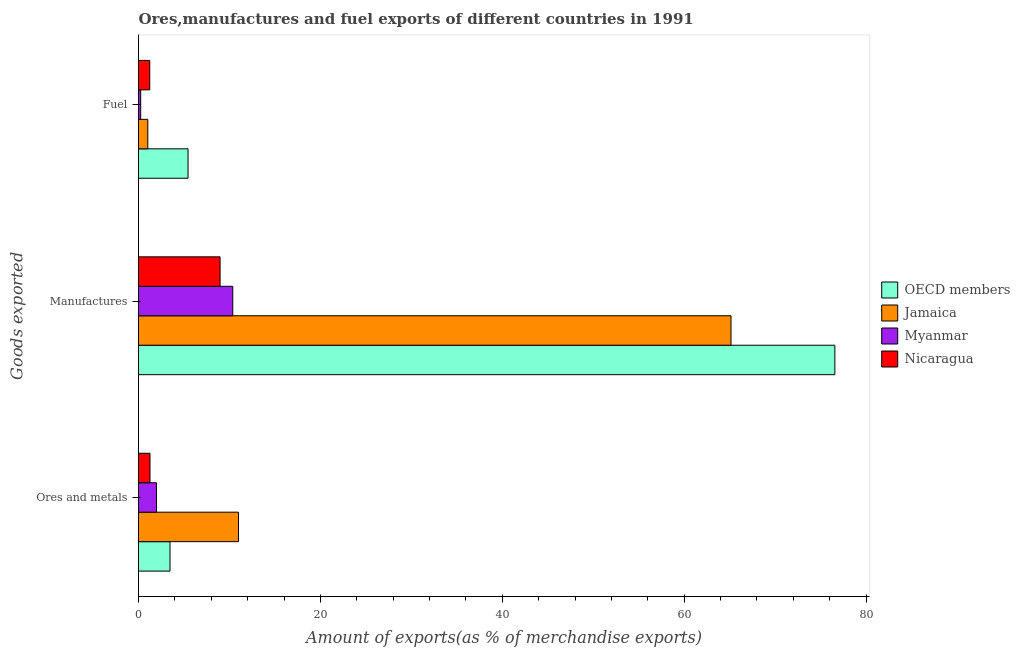How many different coloured bars are there?
Offer a terse response. 4. How many groups of bars are there?
Your answer should be compact. 3. Are the number of bars on each tick of the Y-axis equal?
Offer a very short reply. Yes. How many bars are there on the 2nd tick from the top?
Keep it short and to the point. 4. What is the label of the 3rd group of bars from the top?
Provide a short and direct response. Ores and metals. What is the percentage of fuel exports in OECD members?
Provide a short and direct response. 5.45. Across all countries, what is the maximum percentage of ores and metals exports?
Give a very brief answer. 10.99. Across all countries, what is the minimum percentage of ores and metals exports?
Provide a succinct answer. 1.26. In which country was the percentage of fuel exports minimum?
Offer a very short reply. Myanmar. What is the total percentage of ores and metals exports in the graph?
Ensure brevity in your answer.  17.7. What is the difference between the percentage of fuel exports in OECD members and that in Nicaragua?
Keep it short and to the point. 4.21. What is the difference between the percentage of manufactures exports in Jamaica and the percentage of ores and metals exports in OECD members?
Provide a short and direct response. 61.69. What is the average percentage of ores and metals exports per country?
Ensure brevity in your answer.  4.42. What is the difference between the percentage of manufactures exports and percentage of fuel exports in Nicaragua?
Your response must be concise. 7.73. In how many countries, is the percentage of manufactures exports greater than 68 %?
Keep it short and to the point. 1. What is the ratio of the percentage of ores and metals exports in Jamaica to that in Myanmar?
Provide a short and direct response. 5.55. What is the difference between the highest and the second highest percentage of ores and metals exports?
Provide a short and direct response. 7.53. What is the difference between the highest and the lowest percentage of ores and metals exports?
Provide a succinct answer. 9.73. What does the 3rd bar from the top in Manufactures represents?
Ensure brevity in your answer.  Jamaica. What does the 3rd bar from the bottom in Ores and metals represents?
Give a very brief answer. Myanmar. Are the values on the major ticks of X-axis written in scientific E-notation?
Your response must be concise. No. Does the graph contain any zero values?
Keep it short and to the point. No. Does the graph contain grids?
Ensure brevity in your answer.  No. Where does the legend appear in the graph?
Your answer should be compact. Center right. How many legend labels are there?
Ensure brevity in your answer.  4. What is the title of the graph?
Offer a very short reply. Ores,manufactures and fuel exports of different countries in 1991. What is the label or title of the X-axis?
Your answer should be compact. Amount of exports(as % of merchandise exports). What is the label or title of the Y-axis?
Keep it short and to the point. Goods exported. What is the Amount of exports(as % of merchandise exports) in OECD members in Ores and metals?
Keep it short and to the point. 3.46. What is the Amount of exports(as % of merchandise exports) of Jamaica in Ores and metals?
Keep it short and to the point. 10.99. What is the Amount of exports(as % of merchandise exports) in Myanmar in Ores and metals?
Your response must be concise. 1.98. What is the Amount of exports(as % of merchandise exports) in Nicaragua in Ores and metals?
Keep it short and to the point. 1.26. What is the Amount of exports(as % of merchandise exports) of OECD members in Manufactures?
Offer a very short reply. 76.57. What is the Amount of exports(as % of merchandise exports) of Jamaica in Manufactures?
Offer a very short reply. 65.15. What is the Amount of exports(as % of merchandise exports) of Myanmar in Manufactures?
Offer a very short reply. 10.37. What is the Amount of exports(as % of merchandise exports) in Nicaragua in Manufactures?
Give a very brief answer. 8.97. What is the Amount of exports(as % of merchandise exports) in OECD members in Fuel?
Your answer should be compact. 5.45. What is the Amount of exports(as % of merchandise exports) of Jamaica in Fuel?
Keep it short and to the point. 1.02. What is the Amount of exports(as % of merchandise exports) of Myanmar in Fuel?
Make the answer very short. 0.24. What is the Amount of exports(as % of merchandise exports) of Nicaragua in Fuel?
Keep it short and to the point. 1.24. Across all Goods exported, what is the maximum Amount of exports(as % of merchandise exports) in OECD members?
Keep it short and to the point. 76.57. Across all Goods exported, what is the maximum Amount of exports(as % of merchandise exports) in Jamaica?
Your answer should be compact. 65.15. Across all Goods exported, what is the maximum Amount of exports(as % of merchandise exports) in Myanmar?
Offer a terse response. 10.37. Across all Goods exported, what is the maximum Amount of exports(as % of merchandise exports) of Nicaragua?
Give a very brief answer. 8.97. Across all Goods exported, what is the minimum Amount of exports(as % of merchandise exports) in OECD members?
Make the answer very short. 3.46. Across all Goods exported, what is the minimum Amount of exports(as % of merchandise exports) of Jamaica?
Make the answer very short. 1.02. Across all Goods exported, what is the minimum Amount of exports(as % of merchandise exports) in Myanmar?
Make the answer very short. 0.24. Across all Goods exported, what is the minimum Amount of exports(as % of merchandise exports) in Nicaragua?
Your answer should be very brief. 1.24. What is the total Amount of exports(as % of merchandise exports) of OECD members in the graph?
Provide a short and direct response. 85.48. What is the total Amount of exports(as % of merchandise exports) in Jamaica in the graph?
Your answer should be compact. 77.17. What is the total Amount of exports(as % of merchandise exports) of Myanmar in the graph?
Keep it short and to the point. 12.59. What is the total Amount of exports(as % of merchandise exports) of Nicaragua in the graph?
Offer a very short reply. 11.47. What is the difference between the Amount of exports(as % of merchandise exports) in OECD members in Ores and metals and that in Manufactures?
Ensure brevity in your answer.  -73.11. What is the difference between the Amount of exports(as % of merchandise exports) in Jamaica in Ores and metals and that in Manufactures?
Give a very brief answer. -54.16. What is the difference between the Amount of exports(as % of merchandise exports) in Myanmar in Ores and metals and that in Manufactures?
Keep it short and to the point. -8.39. What is the difference between the Amount of exports(as % of merchandise exports) of Nicaragua in Ores and metals and that in Manufactures?
Your answer should be compact. -7.71. What is the difference between the Amount of exports(as % of merchandise exports) of OECD members in Ores and metals and that in Fuel?
Offer a terse response. -1.98. What is the difference between the Amount of exports(as % of merchandise exports) in Jamaica in Ores and metals and that in Fuel?
Provide a short and direct response. 9.97. What is the difference between the Amount of exports(as % of merchandise exports) in Myanmar in Ores and metals and that in Fuel?
Offer a terse response. 1.74. What is the difference between the Amount of exports(as % of merchandise exports) of Nicaragua in Ores and metals and that in Fuel?
Provide a short and direct response. 0.03. What is the difference between the Amount of exports(as % of merchandise exports) in OECD members in Manufactures and that in Fuel?
Offer a very short reply. 71.13. What is the difference between the Amount of exports(as % of merchandise exports) in Jamaica in Manufactures and that in Fuel?
Your answer should be very brief. 64.13. What is the difference between the Amount of exports(as % of merchandise exports) of Myanmar in Manufactures and that in Fuel?
Make the answer very short. 10.13. What is the difference between the Amount of exports(as % of merchandise exports) in Nicaragua in Manufactures and that in Fuel?
Your response must be concise. 7.73. What is the difference between the Amount of exports(as % of merchandise exports) of OECD members in Ores and metals and the Amount of exports(as % of merchandise exports) of Jamaica in Manufactures?
Ensure brevity in your answer.  -61.69. What is the difference between the Amount of exports(as % of merchandise exports) of OECD members in Ores and metals and the Amount of exports(as % of merchandise exports) of Myanmar in Manufactures?
Give a very brief answer. -6.9. What is the difference between the Amount of exports(as % of merchandise exports) of OECD members in Ores and metals and the Amount of exports(as % of merchandise exports) of Nicaragua in Manufactures?
Ensure brevity in your answer.  -5.51. What is the difference between the Amount of exports(as % of merchandise exports) of Jamaica in Ores and metals and the Amount of exports(as % of merchandise exports) of Myanmar in Manufactures?
Provide a succinct answer. 0.63. What is the difference between the Amount of exports(as % of merchandise exports) of Jamaica in Ores and metals and the Amount of exports(as % of merchandise exports) of Nicaragua in Manufactures?
Ensure brevity in your answer.  2.02. What is the difference between the Amount of exports(as % of merchandise exports) of Myanmar in Ores and metals and the Amount of exports(as % of merchandise exports) of Nicaragua in Manufactures?
Your answer should be compact. -6.99. What is the difference between the Amount of exports(as % of merchandise exports) in OECD members in Ores and metals and the Amount of exports(as % of merchandise exports) in Jamaica in Fuel?
Offer a terse response. 2.44. What is the difference between the Amount of exports(as % of merchandise exports) of OECD members in Ores and metals and the Amount of exports(as % of merchandise exports) of Myanmar in Fuel?
Your answer should be compact. 3.22. What is the difference between the Amount of exports(as % of merchandise exports) of OECD members in Ores and metals and the Amount of exports(as % of merchandise exports) of Nicaragua in Fuel?
Provide a short and direct response. 2.23. What is the difference between the Amount of exports(as % of merchandise exports) of Jamaica in Ores and metals and the Amount of exports(as % of merchandise exports) of Myanmar in Fuel?
Give a very brief answer. 10.75. What is the difference between the Amount of exports(as % of merchandise exports) in Jamaica in Ores and metals and the Amount of exports(as % of merchandise exports) in Nicaragua in Fuel?
Your answer should be compact. 9.76. What is the difference between the Amount of exports(as % of merchandise exports) in Myanmar in Ores and metals and the Amount of exports(as % of merchandise exports) in Nicaragua in Fuel?
Give a very brief answer. 0.74. What is the difference between the Amount of exports(as % of merchandise exports) of OECD members in Manufactures and the Amount of exports(as % of merchandise exports) of Jamaica in Fuel?
Offer a very short reply. 75.55. What is the difference between the Amount of exports(as % of merchandise exports) of OECD members in Manufactures and the Amount of exports(as % of merchandise exports) of Myanmar in Fuel?
Keep it short and to the point. 76.33. What is the difference between the Amount of exports(as % of merchandise exports) in OECD members in Manufactures and the Amount of exports(as % of merchandise exports) in Nicaragua in Fuel?
Keep it short and to the point. 75.34. What is the difference between the Amount of exports(as % of merchandise exports) of Jamaica in Manufactures and the Amount of exports(as % of merchandise exports) of Myanmar in Fuel?
Make the answer very short. 64.91. What is the difference between the Amount of exports(as % of merchandise exports) of Jamaica in Manufactures and the Amount of exports(as % of merchandise exports) of Nicaragua in Fuel?
Provide a short and direct response. 63.92. What is the difference between the Amount of exports(as % of merchandise exports) in Myanmar in Manufactures and the Amount of exports(as % of merchandise exports) in Nicaragua in Fuel?
Provide a succinct answer. 9.13. What is the average Amount of exports(as % of merchandise exports) in OECD members per Goods exported?
Offer a terse response. 28.49. What is the average Amount of exports(as % of merchandise exports) in Jamaica per Goods exported?
Ensure brevity in your answer.  25.72. What is the average Amount of exports(as % of merchandise exports) in Myanmar per Goods exported?
Offer a terse response. 4.2. What is the average Amount of exports(as % of merchandise exports) of Nicaragua per Goods exported?
Provide a succinct answer. 3.82. What is the difference between the Amount of exports(as % of merchandise exports) of OECD members and Amount of exports(as % of merchandise exports) of Jamaica in Ores and metals?
Your answer should be very brief. -7.53. What is the difference between the Amount of exports(as % of merchandise exports) in OECD members and Amount of exports(as % of merchandise exports) in Myanmar in Ores and metals?
Your answer should be compact. 1.48. What is the difference between the Amount of exports(as % of merchandise exports) of OECD members and Amount of exports(as % of merchandise exports) of Nicaragua in Ores and metals?
Your answer should be compact. 2.2. What is the difference between the Amount of exports(as % of merchandise exports) of Jamaica and Amount of exports(as % of merchandise exports) of Myanmar in Ores and metals?
Ensure brevity in your answer.  9.01. What is the difference between the Amount of exports(as % of merchandise exports) in Jamaica and Amount of exports(as % of merchandise exports) in Nicaragua in Ores and metals?
Offer a terse response. 9.73. What is the difference between the Amount of exports(as % of merchandise exports) in Myanmar and Amount of exports(as % of merchandise exports) in Nicaragua in Ores and metals?
Your answer should be very brief. 0.72. What is the difference between the Amount of exports(as % of merchandise exports) of OECD members and Amount of exports(as % of merchandise exports) of Jamaica in Manufactures?
Provide a succinct answer. 11.42. What is the difference between the Amount of exports(as % of merchandise exports) in OECD members and Amount of exports(as % of merchandise exports) in Myanmar in Manufactures?
Offer a very short reply. 66.21. What is the difference between the Amount of exports(as % of merchandise exports) in OECD members and Amount of exports(as % of merchandise exports) in Nicaragua in Manufactures?
Offer a very short reply. 67.6. What is the difference between the Amount of exports(as % of merchandise exports) of Jamaica and Amount of exports(as % of merchandise exports) of Myanmar in Manufactures?
Make the answer very short. 54.79. What is the difference between the Amount of exports(as % of merchandise exports) of Jamaica and Amount of exports(as % of merchandise exports) of Nicaragua in Manufactures?
Your answer should be very brief. 56.18. What is the difference between the Amount of exports(as % of merchandise exports) in Myanmar and Amount of exports(as % of merchandise exports) in Nicaragua in Manufactures?
Your answer should be very brief. 1.4. What is the difference between the Amount of exports(as % of merchandise exports) in OECD members and Amount of exports(as % of merchandise exports) in Jamaica in Fuel?
Give a very brief answer. 4.42. What is the difference between the Amount of exports(as % of merchandise exports) in OECD members and Amount of exports(as % of merchandise exports) in Myanmar in Fuel?
Offer a terse response. 5.21. What is the difference between the Amount of exports(as % of merchandise exports) of OECD members and Amount of exports(as % of merchandise exports) of Nicaragua in Fuel?
Your answer should be compact. 4.21. What is the difference between the Amount of exports(as % of merchandise exports) of Jamaica and Amount of exports(as % of merchandise exports) of Myanmar in Fuel?
Your answer should be compact. 0.78. What is the difference between the Amount of exports(as % of merchandise exports) in Jamaica and Amount of exports(as % of merchandise exports) in Nicaragua in Fuel?
Offer a terse response. -0.21. What is the difference between the Amount of exports(as % of merchandise exports) of Myanmar and Amount of exports(as % of merchandise exports) of Nicaragua in Fuel?
Make the answer very short. -1. What is the ratio of the Amount of exports(as % of merchandise exports) in OECD members in Ores and metals to that in Manufactures?
Offer a terse response. 0.05. What is the ratio of the Amount of exports(as % of merchandise exports) in Jamaica in Ores and metals to that in Manufactures?
Ensure brevity in your answer.  0.17. What is the ratio of the Amount of exports(as % of merchandise exports) of Myanmar in Ores and metals to that in Manufactures?
Make the answer very short. 0.19. What is the ratio of the Amount of exports(as % of merchandise exports) in Nicaragua in Ores and metals to that in Manufactures?
Your answer should be compact. 0.14. What is the ratio of the Amount of exports(as % of merchandise exports) in OECD members in Ores and metals to that in Fuel?
Provide a short and direct response. 0.64. What is the ratio of the Amount of exports(as % of merchandise exports) of Jamaica in Ores and metals to that in Fuel?
Your response must be concise. 10.74. What is the ratio of the Amount of exports(as % of merchandise exports) of Myanmar in Ores and metals to that in Fuel?
Your response must be concise. 8.25. What is the ratio of the Amount of exports(as % of merchandise exports) of Nicaragua in Ores and metals to that in Fuel?
Keep it short and to the point. 1.02. What is the ratio of the Amount of exports(as % of merchandise exports) of OECD members in Manufactures to that in Fuel?
Keep it short and to the point. 14.06. What is the ratio of the Amount of exports(as % of merchandise exports) in Jamaica in Manufactures to that in Fuel?
Keep it short and to the point. 63.65. What is the ratio of the Amount of exports(as % of merchandise exports) of Myanmar in Manufactures to that in Fuel?
Give a very brief answer. 43.21. What is the ratio of the Amount of exports(as % of merchandise exports) in Nicaragua in Manufactures to that in Fuel?
Your answer should be very brief. 7.26. What is the difference between the highest and the second highest Amount of exports(as % of merchandise exports) of OECD members?
Your response must be concise. 71.13. What is the difference between the highest and the second highest Amount of exports(as % of merchandise exports) in Jamaica?
Your answer should be very brief. 54.16. What is the difference between the highest and the second highest Amount of exports(as % of merchandise exports) in Myanmar?
Provide a short and direct response. 8.39. What is the difference between the highest and the second highest Amount of exports(as % of merchandise exports) in Nicaragua?
Offer a terse response. 7.71. What is the difference between the highest and the lowest Amount of exports(as % of merchandise exports) of OECD members?
Offer a very short reply. 73.11. What is the difference between the highest and the lowest Amount of exports(as % of merchandise exports) in Jamaica?
Your response must be concise. 64.13. What is the difference between the highest and the lowest Amount of exports(as % of merchandise exports) in Myanmar?
Provide a short and direct response. 10.13. What is the difference between the highest and the lowest Amount of exports(as % of merchandise exports) of Nicaragua?
Your answer should be compact. 7.73. 